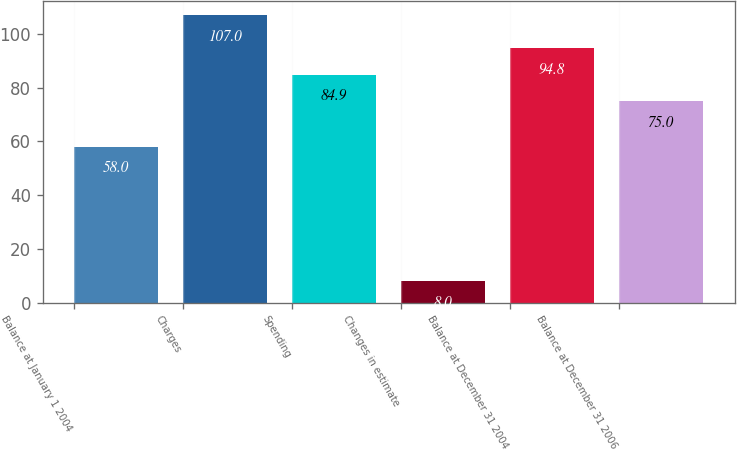Convert chart to OTSL. <chart><loc_0><loc_0><loc_500><loc_500><bar_chart><fcel>Balance at January 1 2004<fcel>Charges<fcel>Spending<fcel>Changes in estimate<fcel>Balance at December 31 2004<fcel>Balance at December 31 2006<nl><fcel>58<fcel>107<fcel>84.9<fcel>8<fcel>94.8<fcel>75<nl></chart> 